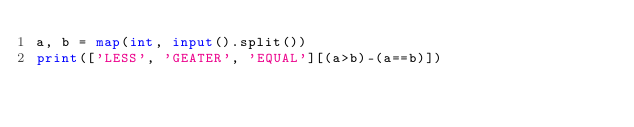<code> <loc_0><loc_0><loc_500><loc_500><_Python_>a, b = map(int, input().split())
print(['LESS', 'GEATER', 'EQUAL'][(a>b)-(a==b)])</code> 